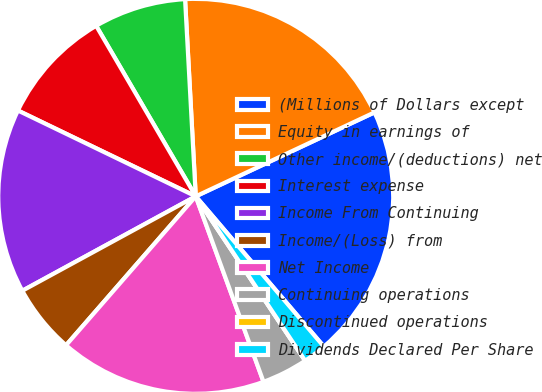Convert chart. <chart><loc_0><loc_0><loc_500><loc_500><pie_chart><fcel>(Millions of Dollars except<fcel>Equity in earnings of<fcel>Other income/(deductions) net<fcel>Interest expense<fcel>Income From Continuing<fcel>Income/(Loss) from<fcel>Net Income<fcel>Continuing operations<fcel>Discontinued operations<fcel>Dividends Declared Per Share<nl><fcel>20.75%<fcel>18.87%<fcel>7.55%<fcel>9.43%<fcel>15.09%<fcel>5.66%<fcel>16.98%<fcel>3.77%<fcel>0.0%<fcel>1.89%<nl></chart> 